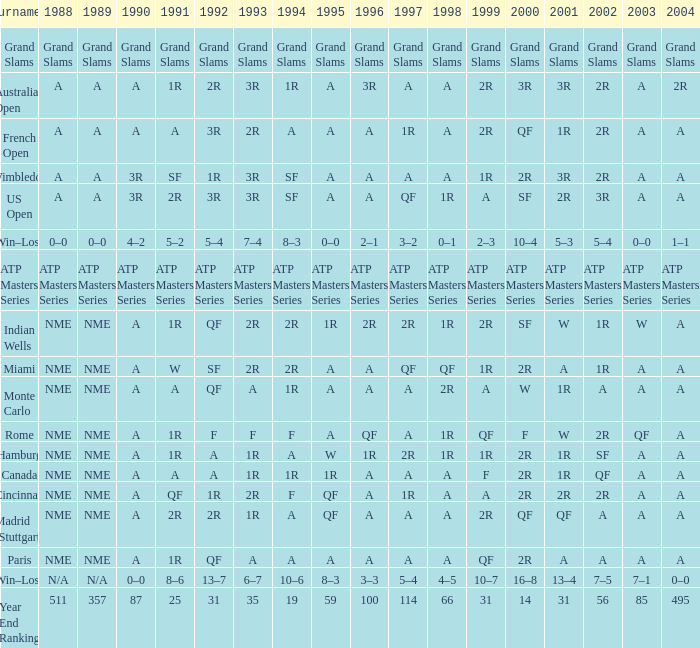What are the displays for 2002 when the value of 1991 is represented by w? 1R. Give me the full table as a dictionary. {'header': ['Tournament', '1988', '1989', '1990', '1991', '1992', '1993', '1994', '1995', '1996', '1997', '1998', '1999', '2000', '2001', '2002', '2003', '2004'], 'rows': [['Grand Slams', 'Grand Slams', 'Grand Slams', 'Grand Slams', 'Grand Slams', 'Grand Slams', 'Grand Slams', 'Grand Slams', 'Grand Slams', 'Grand Slams', 'Grand Slams', 'Grand Slams', 'Grand Slams', 'Grand Slams', 'Grand Slams', 'Grand Slams', 'Grand Slams', 'Grand Slams'], ['Australian Open', 'A', 'A', 'A', '1R', '2R', '3R', '1R', 'A', '3R', 'A', 'A', '2R', '3R', '3R', '2R', 'A', '2R'], ['French Open', 'A', 'A', 'A', 'A', '3R', '2R', 'A', 'A', 'A', '1R', 'A', '2R', 'QF', '1R', '2R', 'A', 'A'], ['Wimbledon', 'A', 'A', '3R', 'SF', '1R', '3R', 'SF', 'A', 'A', 'A', 'A', '1R', '2R', '3R', '2R', 'A', 'A'], ['US Open', 'A', 'A', '3R', '2R', '3R', '3R', 'SF', 'A', 'A', 'QF', '1R', 'A', 'SF', '2R', '3R', 'A', 'A'], ['Win–Loss', '0–0', '0–0', '4–2', '5–2', '5–4', '7–4', '8–3', '0–0', '2–1', '3–2', '0–1', '2–3', '10–4', '5–3', '5–4', '0–0', '1–1'], ['ATP Masters Series', 'ATP Masters Series', 'ATP Masters Series', 'ATP Masters Series', 'ATP Masters Series', 'ATP Masters Series', 'ATP Masters Series', 'ATP Masters Series', 'ATP Masters Series', 'ATP Masters Series', 'ATP Masters Series', 'ATP Masters Series', 'ATP Masters Series', 'ATP Masters Series', 'ATP Masters Series', 'ATP Masters Series', 'ATP Masters Series', 'ATP Masters Series'], ['Indian Wells', 'NME', 'NME', 'A', '1R', 'QF', '2R', '2R', '1R', '2R', '2R', '1R', '2R', 'SF', 'W', '1R', 'W', 'A'], ['Miami', 'NME', 'NME', 'A', 'W', 'SF', '2R', '2R', 'A', 'A', 'QF', 'QF', '1R', '2R', 'A', '1R', 'A', 'A'], ['Monte Carlo', 'NME', 'NME', 'A', 'A', 'QF', 'A', '1R', 'A', 'A', 'A', '2R', 'A', 'W', '1R', 'A', 'A', 'A'], ['Rome', 'NME', 'NME', 'A', '1R', 'F', 'F', 'F', 'A', 'QF', 'A', '1R', 'QF', 'F', 'W', '2R', 'QF', 'A'], ['Hamburg', 'NME', 'NME', 'A', '1R', 'A', '1R', 'A', 'W', '1R', '2R', '1R', '1R', '2R', '1R', 'SF', 'A', 'A'], ['Canada', 'NME', 'NME', 'A', 'A', 'A', '1R', '1R', '1R', 'A', 'A', 'A', 'F', '2R', '1R', 'QF', 'A', 'A'], ['Cincinnati', 'NME', 'NME', 'A', 'QF', '1R', '2R', 'F', 'QF', 'A', '1R', 'A', 'A', '2R', '2R', '2R', 'A', 'A'], ['Madrid (Stuttgart)', 'NME', 'NME', 'A', '2R', '2R', '1R', 'A', 'QF', 'A', 'A', 'A', '2R', 'QF', 'QF', 'A', 'A', 'A'], ['Paris', 'NME', 'NME', 'A', '1R', 'QF', 'A', 'A', 'A', 'A', 'A', 'A', 'QF', '2R', 'A', 'A', 'A', 'A'], ['Win–Loss', 'N/A', 'N/A', '0–0', '8–6', '13–7', '6–7', '10–6', '8–3', '3–3', '5–4', '4–5', '10–7', '16–8', '13–4', '7–5', '7–1', '0–0'], ['Year End Ranking', '511', '357', '87', '25', '31', '35', '19', '59', '100', '114', '66', '31', '14', '31', '56', '85', '495']]} 